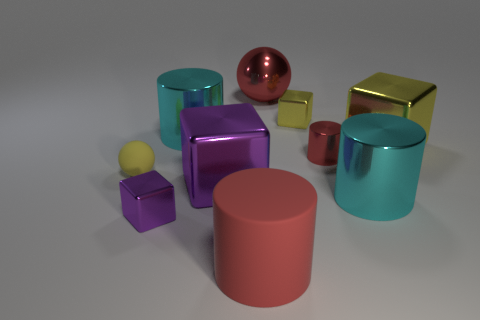There is a small purple cube; are there any large objects behind it?
Give a very brief answer. Yes. What number of red things are there?
Provide a short and direct response. 3. What number of large blocks are right of the tiny red shiny cylinder that is behind the matte cylinder?
Give a very brief answer. 1. There is a tiny rubber sphere; is its color the same as the big metallic cylinder to the right of the tiny cylinder?
Your answer should be very brief. No. How many other things are the same shape as the small yellow rubber object?
Make the answer very short. 1. There is a big red object in front of the tiny yellow matte thing; what is it made of?
Your response must be concise. Rubber. There is a big cyan thing left of the large purple metallic object; does it have the same shape as the large yellow object?
Your answer should be very brief. No. Are there any shiny cylinders that have the same size as the red rubber object?
Your answer should be very brief. Yes. Is the shape of the small yellow metal object the same as the big red thing that is behind the big purple metallic object?
Your response must be concise. No. The tiny thing that is the same color as the tiny matte sphere is what shape?
Provide a short and direct response. Cube. 